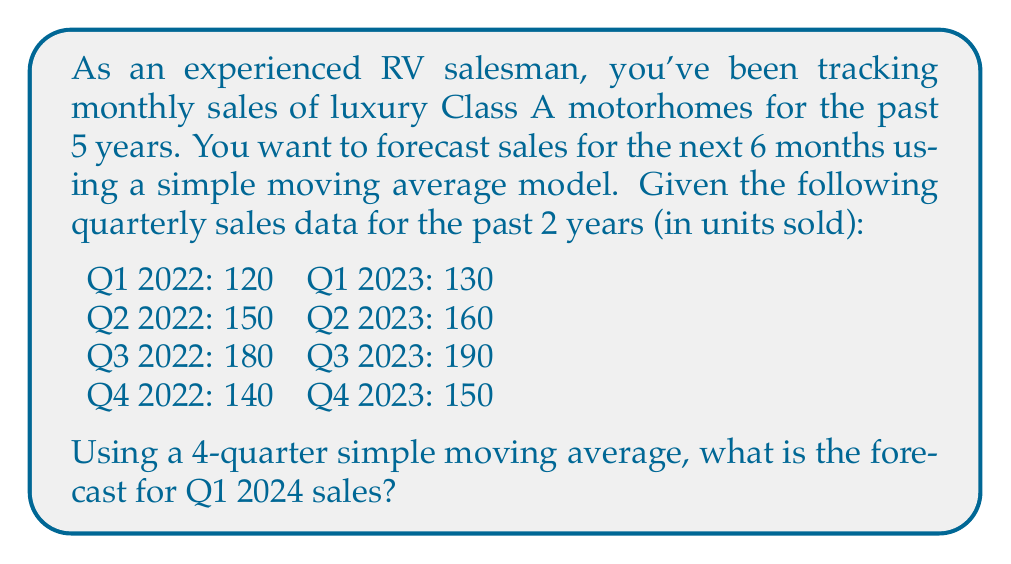Can you answer this question? To solve this problem, we'll use a 4-quarter simple moving average model. This method calculates the average of the last 4 quarters to predict the next quarter's sales.

Step 1: Calculate the 4-quarter moving averages:

For Q4 2022:
$$ MA_{Q4 2022} = \frac{120 + 150 + 180 + 140}{4} = 147.5 $$

For Q1 2023:
$$ MA_{Q1 2023} = \frac{150 + 180 + 140 + 130}{4} = 150 $$

For Q2 2023:
$$ MA_{Q2 2023} = \frac{180 + 140 + 130 + 160}{4} = 152.5 $$

For Q3 2023:
$$ MA_{Q3 2023} = \frac{140 + 130 + 160 + 190}{4} = 155 $$

For Q4 2023:
$$ MA_{Q4 2023} = \frac{130 + 160 + 190 + 150}{4} = 157.5 $$

Step 2: The forecast for Q1 2024 is the last calculated moving average, which is the moving average for Q4 2023.

Therefore, the forecast for Q1 2024 is 157.5 units.

This method assumes that the trend and seasonality observed in the past 4 quarters will continue into the next quarter, which is often a reasonable assumption for short-term forecasting in the RV industry.
Answer: 157.5 units 